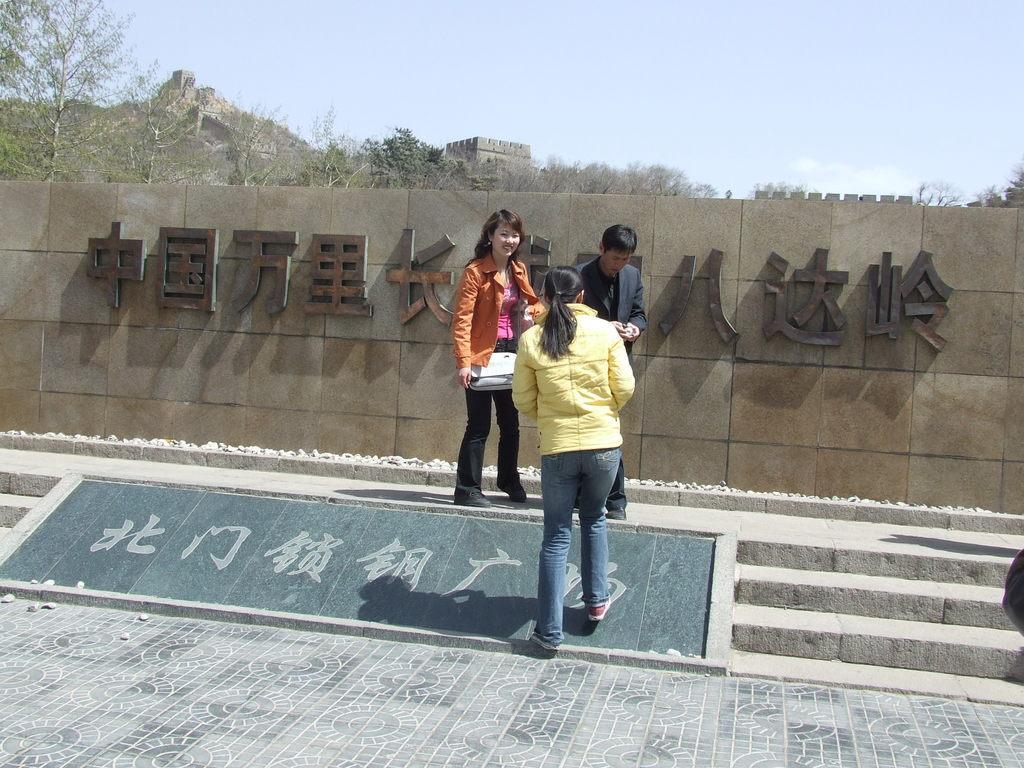Can you describe this image briefly? In this picture, we see two women and a man is standing. The woman on the left side is wearing the bag and she is smiling. At the bottom, we see the pavement. On the right side, we see the staircase. Behind them, we see a wall and we see the text on the wall. In the background, we see the trees, rocks and a castle or a fort. At the top, we see the sky. 